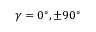Convert formula to latex. <formula><loc_0><loc_0><loc_500><loc_500>\gamma = 0 ^ { \circ } , \pm 9 0 ^ { \circ }</formula> 